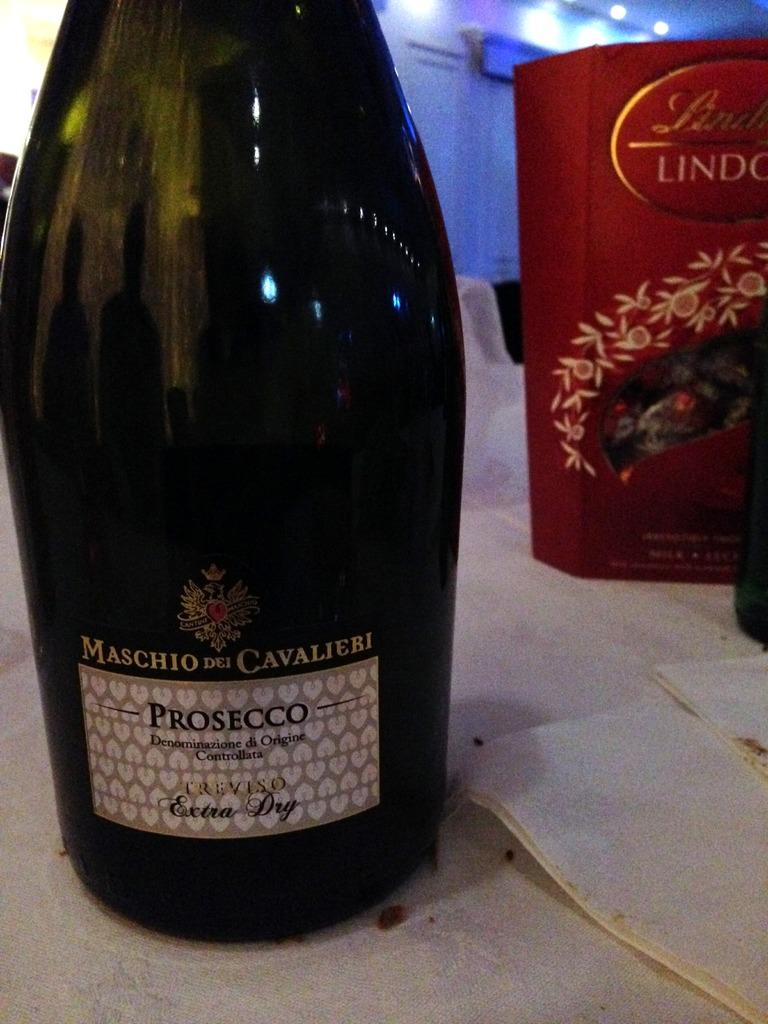<image>
Relay a brief, clear account of the picture shown. Bottle of Maschio del Cavalieri sitting in front of Lindt chocolates. 